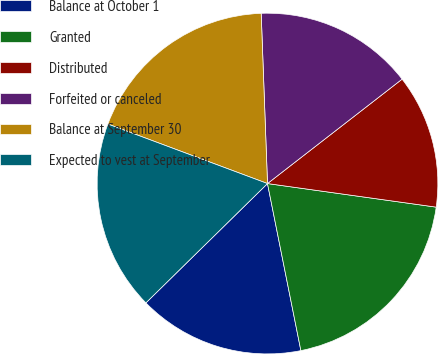<chart> <loc_0><loc_0><loc_500><loc_500><pie_chart><fcel>Balance at October 1<fcel>Granted<fcel>Distributed<fcel>Forfeited or canceled<fcel>Balance at September 30<fcel>Expected to vest at September<nl><fcel>15.79%<fcel>19.65%<fcel>12.71%<fcel>15.09%<fcel>18.73%<fcel>18.03%<nl></chart> 